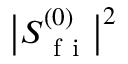Convert formula to latex. <formula><loc_0><loc_0><loc_500><loc_500>\left | S _ { f i } ^ { ( 0 ) } \right | ^ { 2 }</formula> 